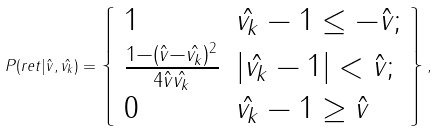Convert formula to latex. <formula><loc_0><loc_0><loc_500><loc_500>P ( r e t | \hat { v } , \hat { v _ { k } } ) = \left \{ \begin{array} { l l } 1 & \hat { v _ { k } } - 1 \leq - \hat { v } ; \\ \frac { 1 - ( \hat { v } - \hat { v _ { k } } ) ^ { 2 } } { 4 \hat { v } \hat { v _ { k } } } & | \hat { v _ { k } } - 1 | < \hat { v } ; \\ 0 & \hat { v _ { k } } - 1 \geq \hat { v } \end{array} \right \} ,</formula> 